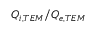<formula> <loc_0><loc_0><loc_500><loc_500>Q _ { i , T E M } / Q _ { e , T E M }</formula> 